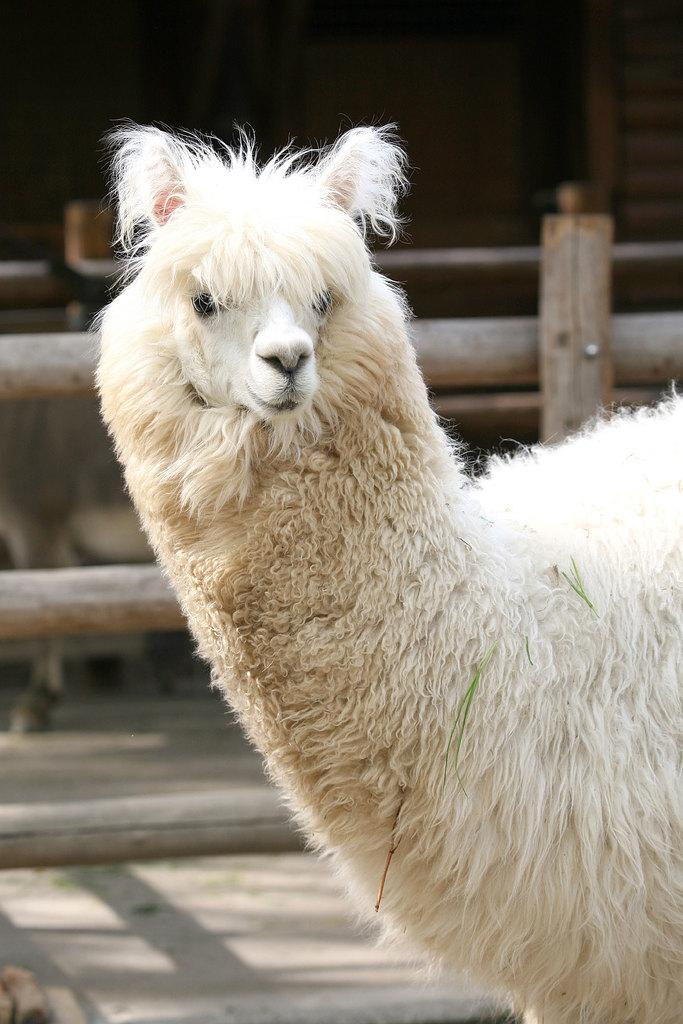What is the main subject in the center of the image? There is an animal in the center of the image. What can be seen in the background of the image? There is a fence in the background of the image. What is the price of the sofa in the image? There is no sofa present in the image, so it is not possible to determine its price. 